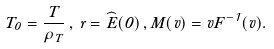<formula> <loc_0><loc_0><loc_500><loc_500>T _ { 0 } = \frac { T } { \rho _ { T } } \, , \, r = \widehat { E } ( 0 ) \, , M ( v ) = v F ^ { - 1 } ( v ) .</formula> 